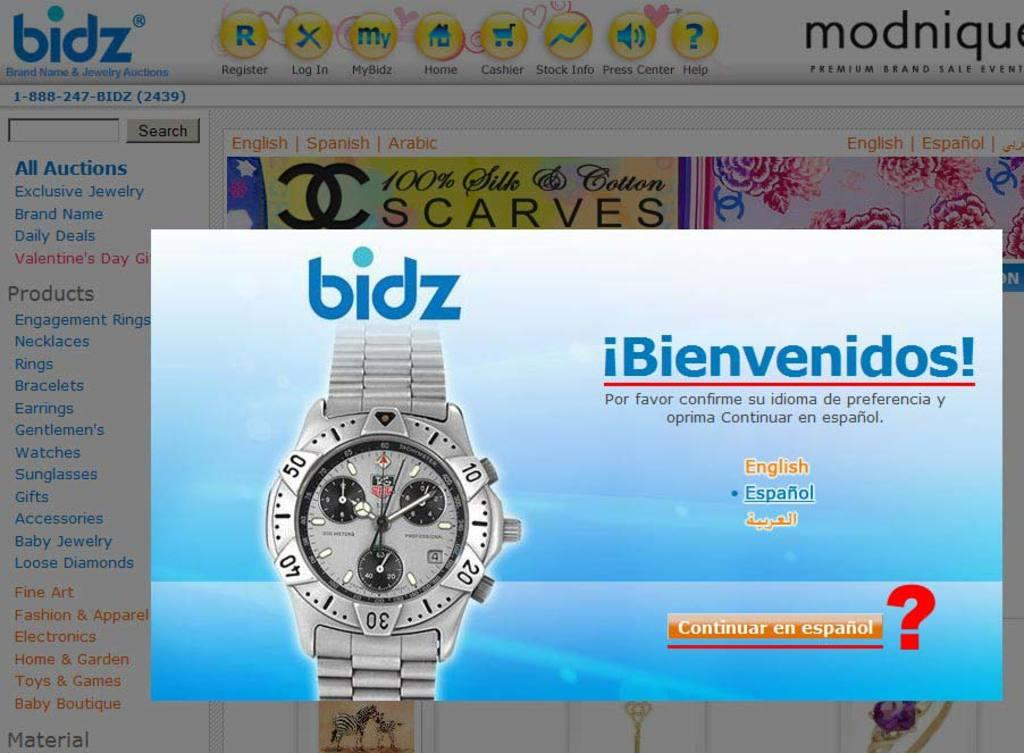<image>
Create a compact narrative representing the image presented. A website with an advertisement of Chanel scarves. 